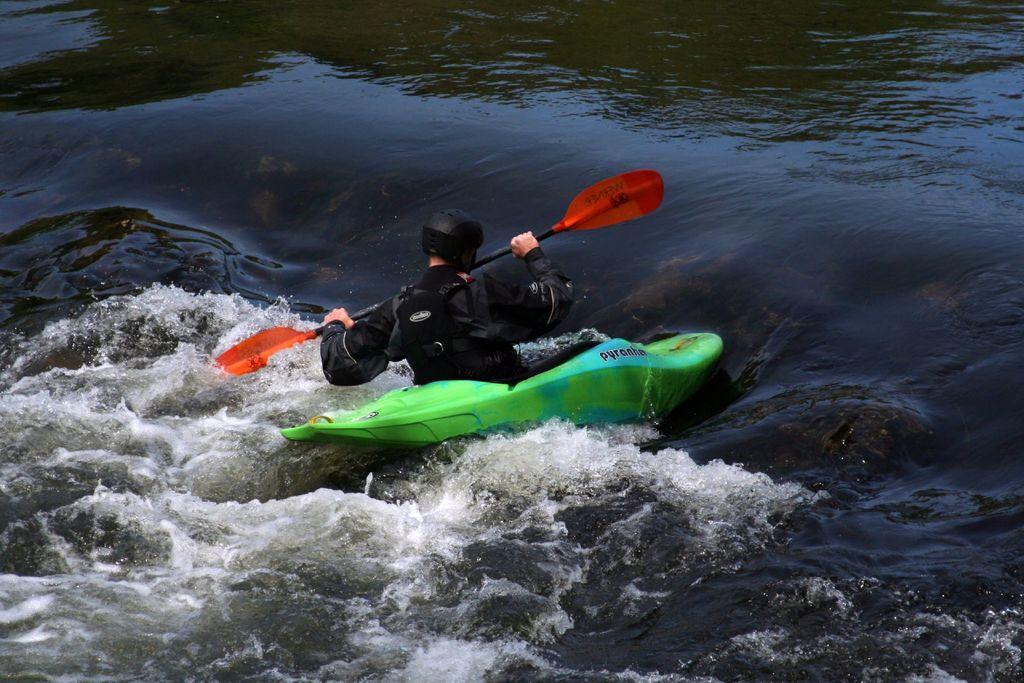How would you summarize this image in a sentence or two? In this image there is one person who is in a boat holding a stick and riding, and there is a river. 